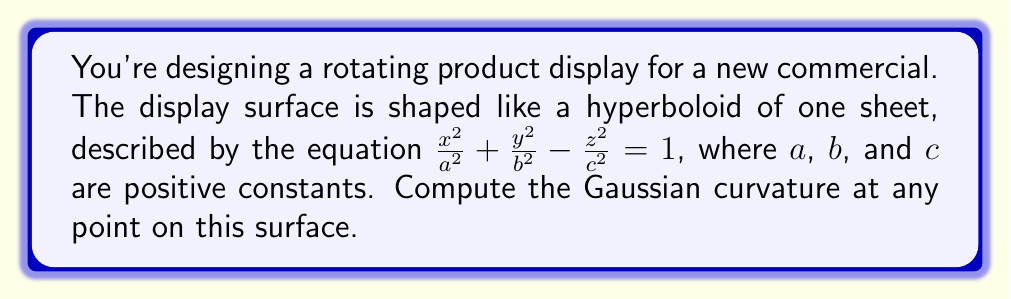Give your solution to this math problem. To find the Gaussian curvature, we'll follow these steps:

1) First, we need to parameterize the surface. Let's use:
   $x = a \cosh u \cos v$
   $y = b \cosh u \sin v$
   $z = c \sinh u$

2) Calculate the partial derivatives:
   $x_u = a \sinh u \cos v$, $x_v = -a \cosh u \sin v$
   $y_u = b \sinh u \sin v$, $y_v = b \cosh u \cos v$
   $z_u = c \cosh u$, $z_v = 0$

3) Compute the coefficients of the first fundamental form:
   $E = x_u^2 + y_u^2 + z_u^2 = a^2 \sinh^2 u \cos^2 v + b^2 \sinh^2 u \sin^2 v + c^2 \cosh^2 u$
   $F = x_u x_v + y_u y_v + z_u z_v = (b^2 - a^2) \sinh u \cosh u \sin v \cos v$
   $G = x_v^2 + y_v^2 + z_v^2 = a^2 \cosh^2 u \sin^2 v + b^2 \cosh^2 u \cos^2 v$

4) Calculate the second partial derivatives:
   $x_{uu} = a \cosh u \cos v$, $x_{uv} = -a \sinh u \sin v$, $x_{vv} = -a \cosh u \cos v$
   $y_{uu} = b \cosh u \sin v$, $y_{uv} = b \sinh u \cos v$, $y_{vv} = -b \cosh u \sin v$
   $z_{uu} = c \sinh u$, $z_{uv} = 0$, $z_{vv} = 0$

5) Compute the coefficients of the second fundamental form:
   $L = \frac{x_{uu}x_v + y_{uu}y_v + z_{uu}z_v}{\sqrt{EG-F^2}}$
   $M = \frac{x_{uv}x_v + y_{uv}y_v + z_{uv}z_v}{\sqrt{EG-F^2}}$
   $N = \frac{x_{vv}x_v + y_{vv}y_v + z_{vv}z_v}{\sqrt{EG-F^2}}$

6) The Gaussian curvature is given by:
   $K = \frac{LN - M^2}{EG - F^2}$

7) After simplification, we get:
   $K = -\frac{1}{a^2b^2c^2}(a^2 \cosh^2 u + b^2 \cosh^2 u - c^2 \sinh^2 u)$

8) This can be further simplified using the equation of the hyperboloid:
   $\frac{x^2}{a^2} + \frac{y^2}{b^2} - \frac{z^2}{c^2} = 1$
   $\cosh^2 u \cos^2 v + \cosh^2 u \sin^2 v - \sinh^2 u = 1$
   $\cosh^2 u - \sinh^2 u = 1$

9) Substituting this into our expression for K:
   $K = -\frac{1}{a^2b^2c^2}(a^2 + b^2 - c^2)$
Answer: $K = -\frac{a^2 + b^2 - c^2}{a^2b^2c^2}$ 